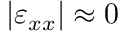Convert formula to latex. <formula><loc_0><loc_0><loc_500><loc_500>| \varepsilon _ { x x } | \approx 0</formula> 